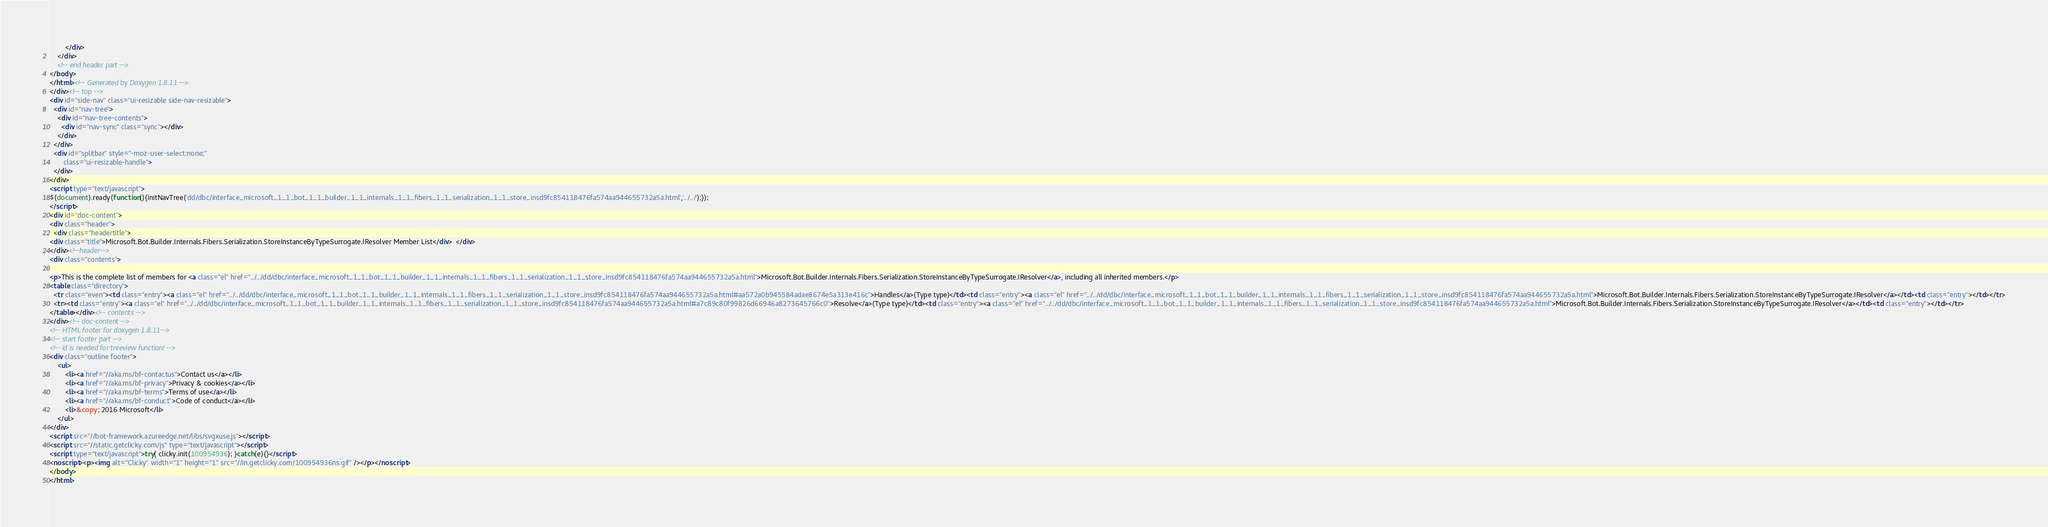<code> <loc_0><loc_0><loc_500><loc_500><_HTML_>        </div>
    </div>
    <!-- end header part -->
</body>
</html><!-- Generated by Doxygen 1.8.11 -->
</div><!-- top -->
<div id="side-nav" class="ui-resizable side-nav-resizable">
  <div id="nav-tree">
    <div id="nav-tree-contents">
      <div id="nav-sync" class="sync"></div>
    </div>
  </div>
  <div id="splitbar" style="-moz-user-select:none;" 
       class="ui-resizable-handle">
  </div>
</div>
<script type="text/javascript">
$(document).ready(function(){initNavTree('dd/dbc/interface_microsoft_1_1_bot_1_1_builder_1_1_internals_1_1_fibers_1_1_serialization_1_1_store_insd9fc854118476fa574aa944655732a5a.html','../../');});
</script>
<div id="doc-content">
<div class="header">
  <div class="headertitle">
<div class="title">Microsoft.Bot.Builder.Internals.Fibers.Serialization.StoreInstanceByTypeSurrogate.IResolver Member List</div>  </div>
</div><!--header-->
<div class="contents">

<p>This is the complete list of members for <a class="el" href="../../dd/dbc/interface_microsoft_1_1_bot_1_1_builder_1_1_internals_1_1_fibers_1_1_serialization_1_1_store_insd9fc854118476fa574aa944655732a5a.html">Microsoft.Bot.Builder.Internals.Fibers.Serialization.StoreInstanceByTypeSurrogate.IResolver</a>, including all inherited members.</p>
<table class="directory">
  <tr class="even"><td class="entry"><a class="el" href="../../dd/dbc/interface_microsoft_1_1_bot_1_1_builder_1_1_internals_1_1_fibers_1_1_serialization_1_1_store_insd9fc854118476fa574aa944655732a5a.html#aa572a0b945584adae8674e5a313e416c">Handles</a>(Type type)</td><td class="entry"><a class="el" href="../../dd/dbc/interface_microsoft_1_1_bot_1_1_builder_1_1_internals_1_1_fibers_1_1_serialization_1_1_store_insd9fc854118476fa574aa944655732a5a.html">Microsoft.Bot.Builder.Internals.Fibers.Serialization.StoreInstanceByTypeSurrogate.IResolver</a></td><td class="entry"></td></tr>
  <tr><td class="entry"><a class="el" href="../../dd/dbc/interface_microsoft_1_1_bot_1_1_builder_1_1_internals_1_1_fibers_1_1_serialization_1_1_store_insd9fc854118476fa574aa944655732a5a.html#a7c89c80f99826d66946a8273645766c0">Resolve</a>(Type type)</td><td class="entry"><a class="el" href="../../dd/dbc/interface_microsoft_1_1_bot_1_1_builder_1_1_internals_1_1_fibers_1_1_serialization_1_1_store_insd9fc854118476fa574aa944655732a5a.html">Microsoft.Bot.Builder.Internals.Fibers.Serialization.StoreInstanceByTypeSurrogate.IResolver</a></td><td class="entry"></td></tr>
</table></div><!-- contents -->
</div><!-- doc-content -->
<!-- HTML footer for doxygen 1.8.11-->
<!-- start footer part -->
<!-- id is needed for treeview function! -->
<div class="outline footer">
    <ul>
        <li><a href="//aka.ms/bf-contactus">Contact us</a></li>
        <li><a href="//aka.ms/bf-privacy">Privacy & cookies</a></li>
        <li><a href="//aka.ms/bf-terms">Terms of use</a></li>
        <li><a href="//aka.ms/bf-conduct">Code of conduct</a></li>
        <li>&copy; 2016 Microsoft</li>
    </ul>
</div>
<script src="//bot-framework.azureedge.net/libs/svgxuse.js"></script>
<script src="//static.getclicky.com/js" type="text/javascript"></script>
<script type="text/javascript">try{ clicky.init(100954936); }catch(e){}</script>
<noscript><p><img alt="Clicky" width="1" height="1" src="//in.getclicky.com/100954936ns.gif" /></p></noscript>
</body>
</html>
</code> 